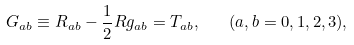Convert formula to latex. <formula><loc_0><loc_0><loc_500><loc_500>G _ { a b } \equiv R _ { a b } - \frac { 1 } { 2 } R g _ { a b } = T _ { a b } , \quad ( a , b = 0 , 1 , 2 , 3 ) ,</formula> 